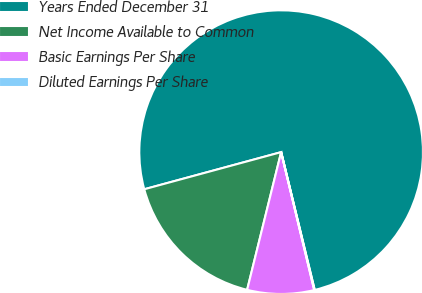Convert chart to OTSL. <chart><loc_0><loc_0><loc_500><loc_500><pie_chart><fcel>Years Ended December 31<fcel>Net Income Available to Common<fcel>Basic Earnings Per Share<fcel>Diluted Earnings Per Share<nl><fcel>75.41%<fcel>16.93%<fcel>7.6%<fcel>0.06%<nl></chart> 